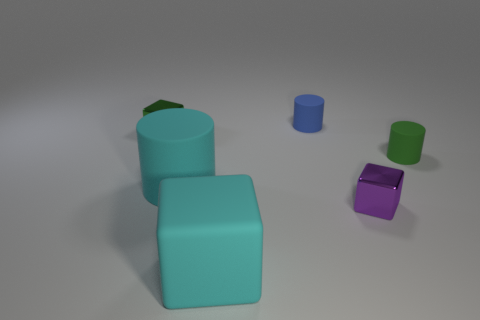Add 3 large cyan things. How many objects exist? 9 Add 1 small blue spheres. How many small blue spheres exist? 1 Subtract 0 purple balls. How many objects are left? 6 Subtract all cylinders. Subtract all large shiny cylinders. How many objects are left? 3 Add 1 green metallic cubes. How many green metallic cubes are left? 2 